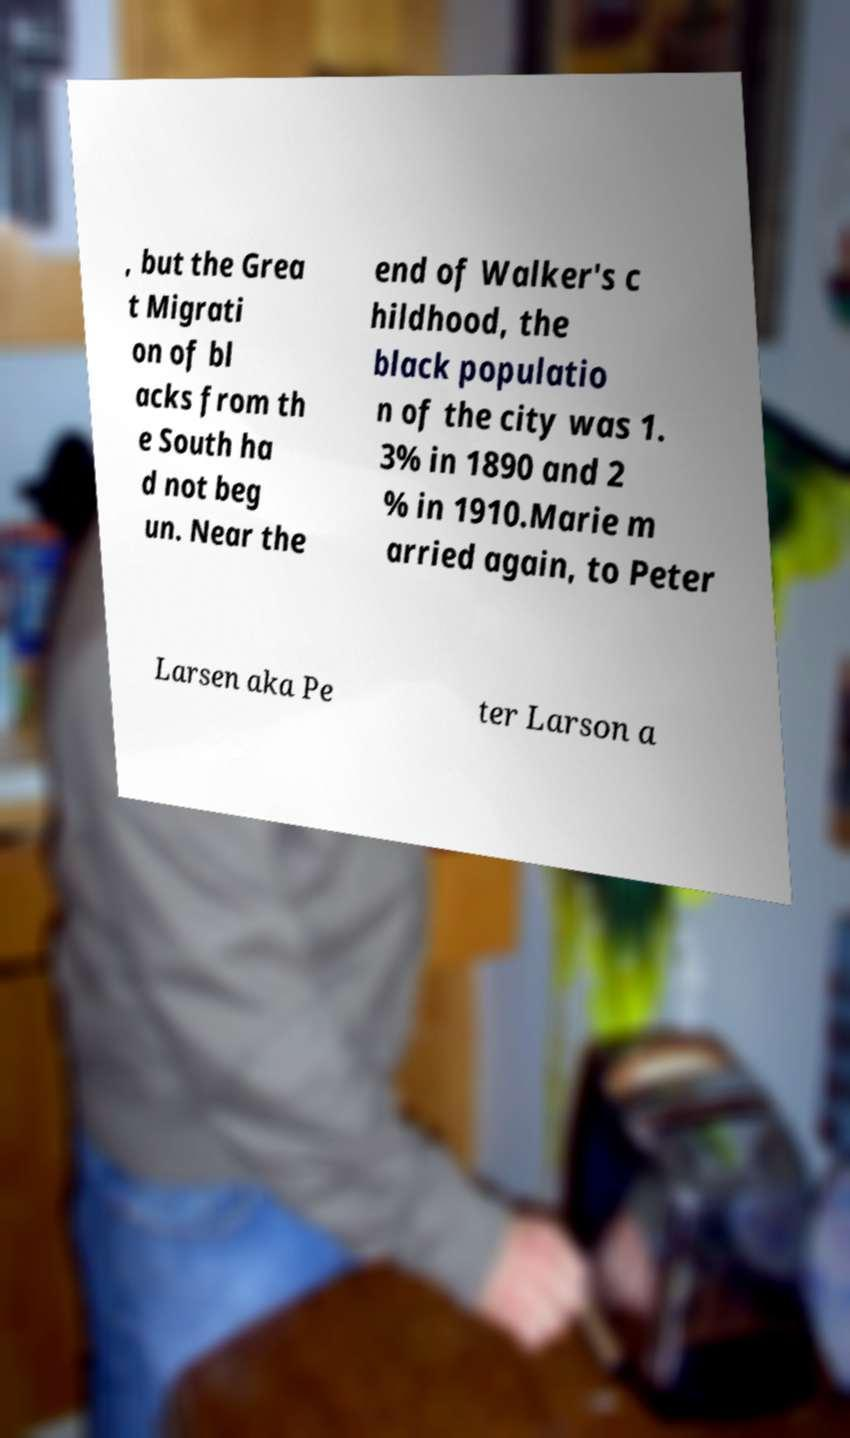Please read and relay the text visible in this image. What does it say? , but the Grea t Migrati on of bl acks from th e South ha d not beg un. Near the end of Walker's c hildhood, the black populatio n of the city was 1. 3% in 1890 and 2 % in 1910.Marie m arried again, to Peter Larsen aka Pe ter Larson a 